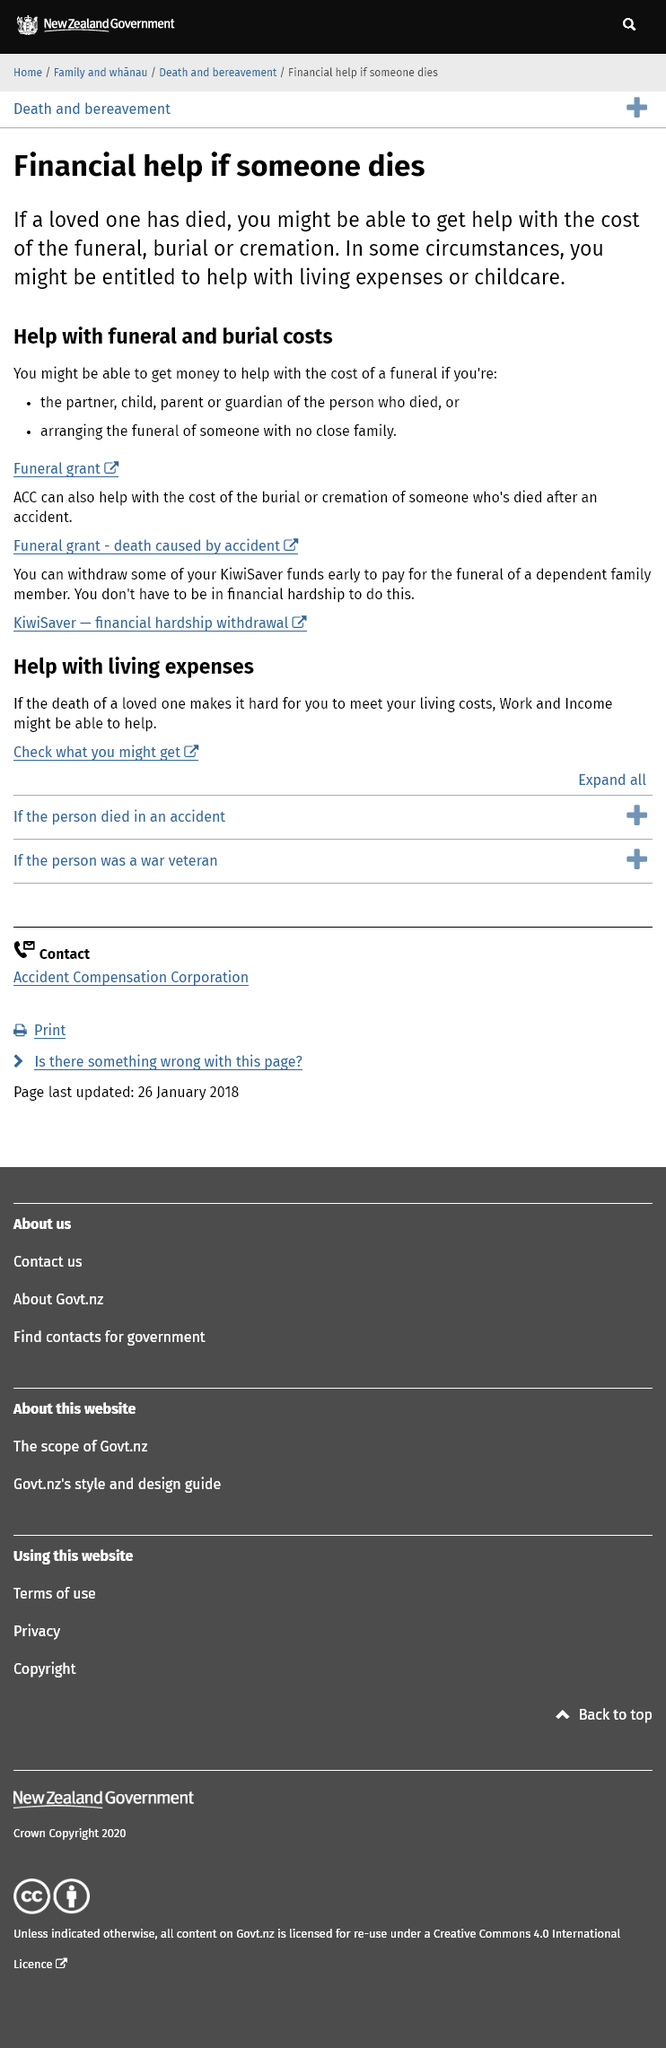Draw attention to some important aspects in this diagram. It is possible to receive assistance with the cost of cremations and burials if a loved one has passed away. Those individuals who are in a position to secure financial assistance for a funeral may include the deceased person's partner, child, parent or guardian, or someone who is responsible for arranging the funeral of someone with no close family ties. Yes, in some circumstances, there may be financial help available for childcare or living expenses in addition to the cost of the funeral and burial or cremation. 